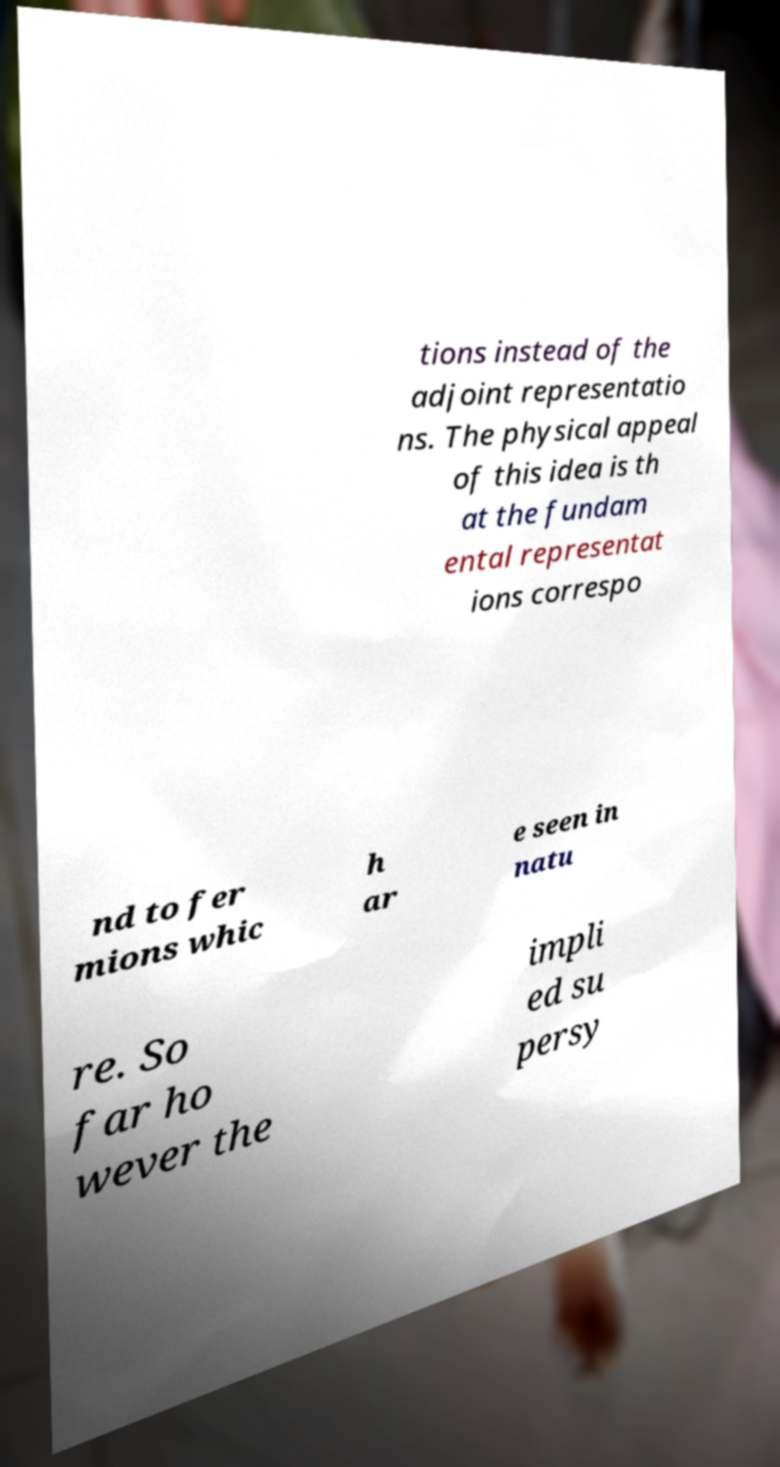Could you extract and type out the text from this image? tions instead of the adjoint representatio ns. The physical appeal of this idea is th at the fundam ental representat ions correspo nd to fer mions whic h ar e seen in natu re. So far ho wever the impli ed su persy 